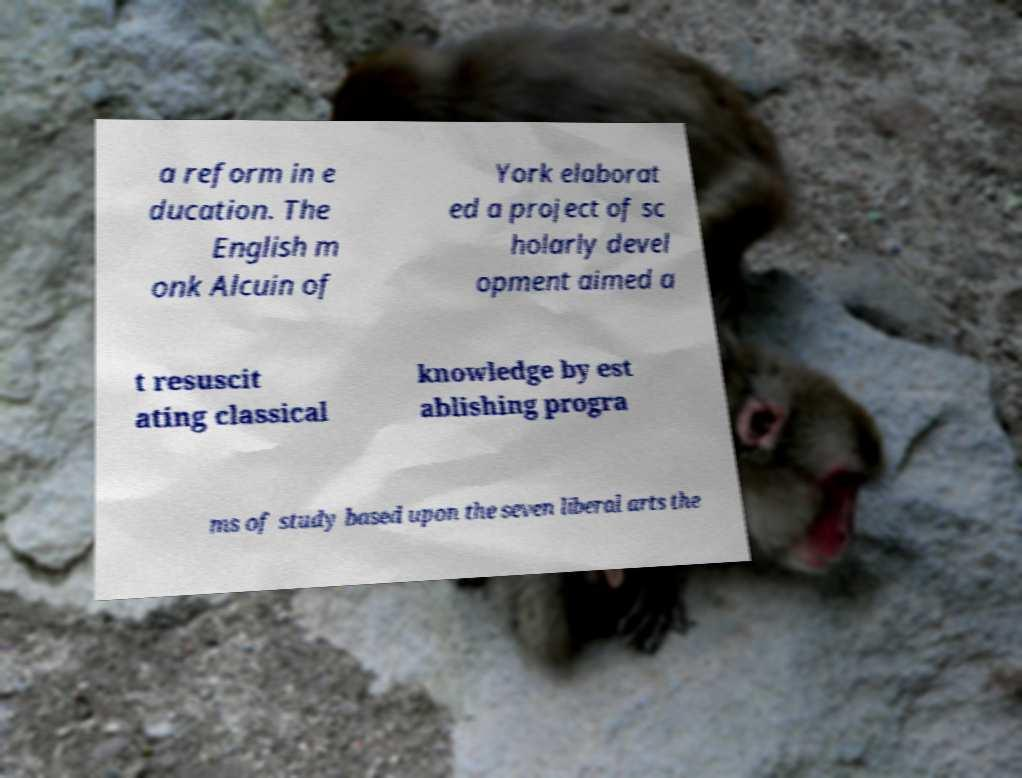Please read and relay the text visible in this image. What does it say? a reform in e ducation. The English m onk Alcuin of York elaborat ed a project of sc holarly devel opment aimed a t resuscit ating classical knowledge by est ablishing progra ms of study based upon the seven liberal arts the 